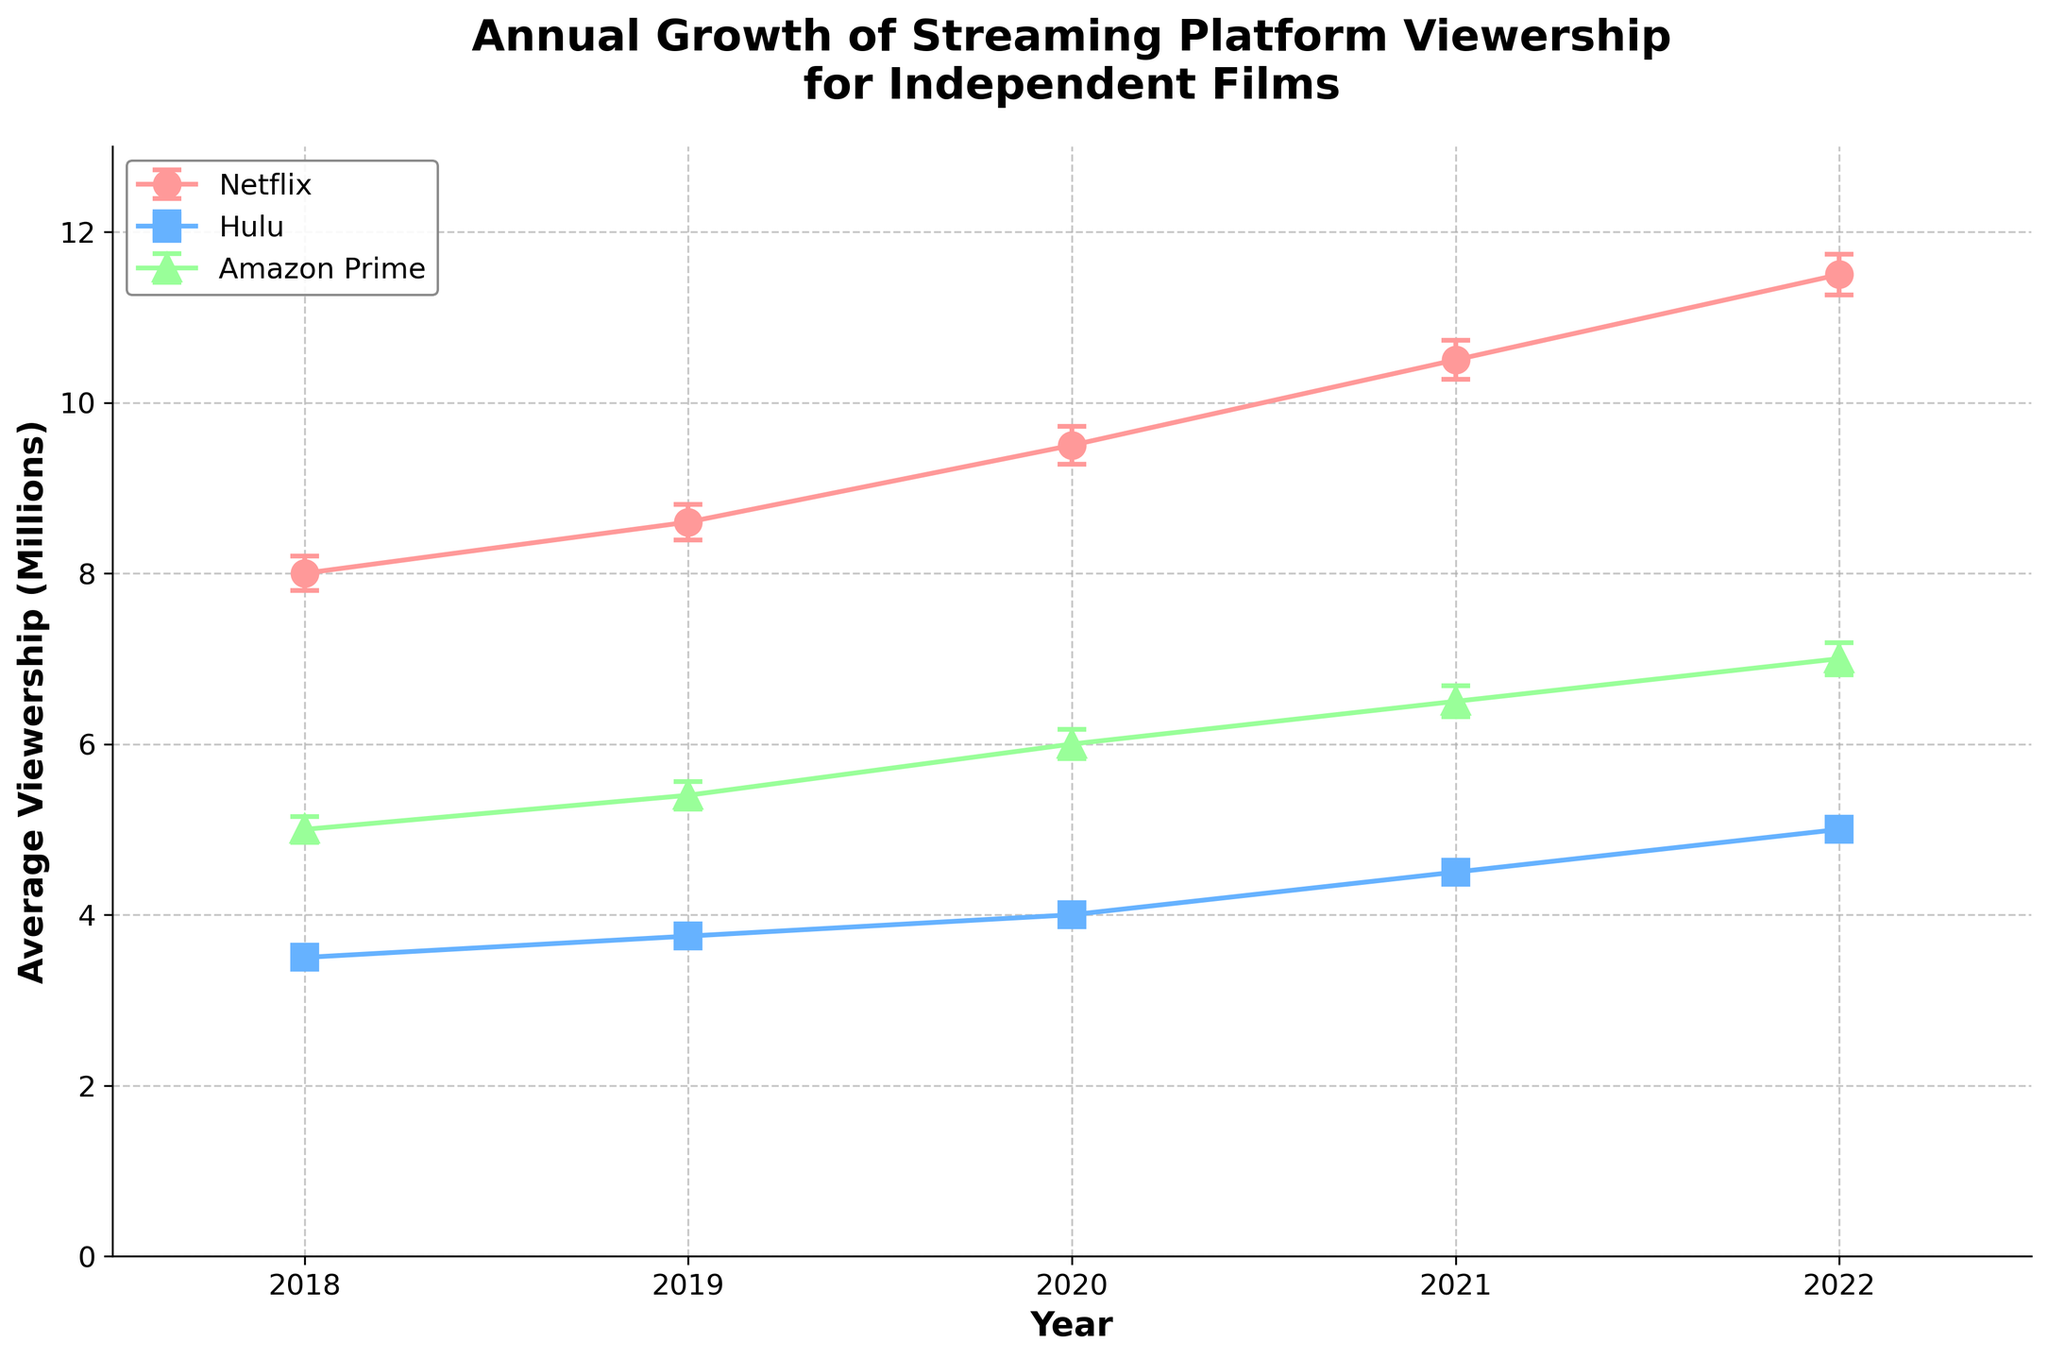What is the title of the plot? The title is usually prominently displayed at the top of the plot. Here it reads "Annual Growth of Streaming Platform Viewership for Independent Films".
Answer: Annual Growth of Streaming Platform Viewership for Independent Films Which streaming platform had the highest viewership in 2018? By looking at the plot, find the data point for each platform label in 2018. The highest viewership in 2018 was for Netflix.
Answer: Netflix What color represents Hulu on the plot? Identify the line associated with Hulu and observe its color. Hulu is represented by a blue line.
Answer: Blue How did Netflix's viewership change from 2018 to 2022? Compare the data points for Netflix in 2018 and 2022. The viewership increased from 8,000,000 in 2018 to 11,500,000 in 2022.
Answer: Increased In which year did Amazon Prime have a viewership lower than 6,000,000? Identify the data points for Amazon Prime across the years and look for those that are below 6,000,000. In 2018 and 2019, the viewership was below 6,000,000.
Answer: 2018 and 2019 What is the average viewership of Hulu from 2018 to 2022? Add the viewership values for Hulu from 2018 to 2022 and divide by the number of years. (3,500,000 + 3,750,000 + 4,000,000 + 4,500,000 + 5,000,000) / 5 = 20,750,000 / 5 = 4,150,000.
Answer: 4,150,000 Which platform had the smallest standard error in 2021? Compare the error bars size or the standard error values in 2021 for each platform. Hulu had the smallest standard error, which was 130,000.
Answer: Hulu Which streaming platform shows the most consistent growth? Observe the trend lines for each platform. Netflix displays the most consistent growth, steadily increasing each year.
Answer: Netflix What is the approximate total viewership for Amazon Prime in 2020 shown on the plot including its error range? Find the data point for Amazon Prime in 2020. The viewership is 6,000,000 with an error of 170,000, so the total range is approximately 5,830,000 to 6,170,000.
Answer: 5,830,000 to 6,170,000 